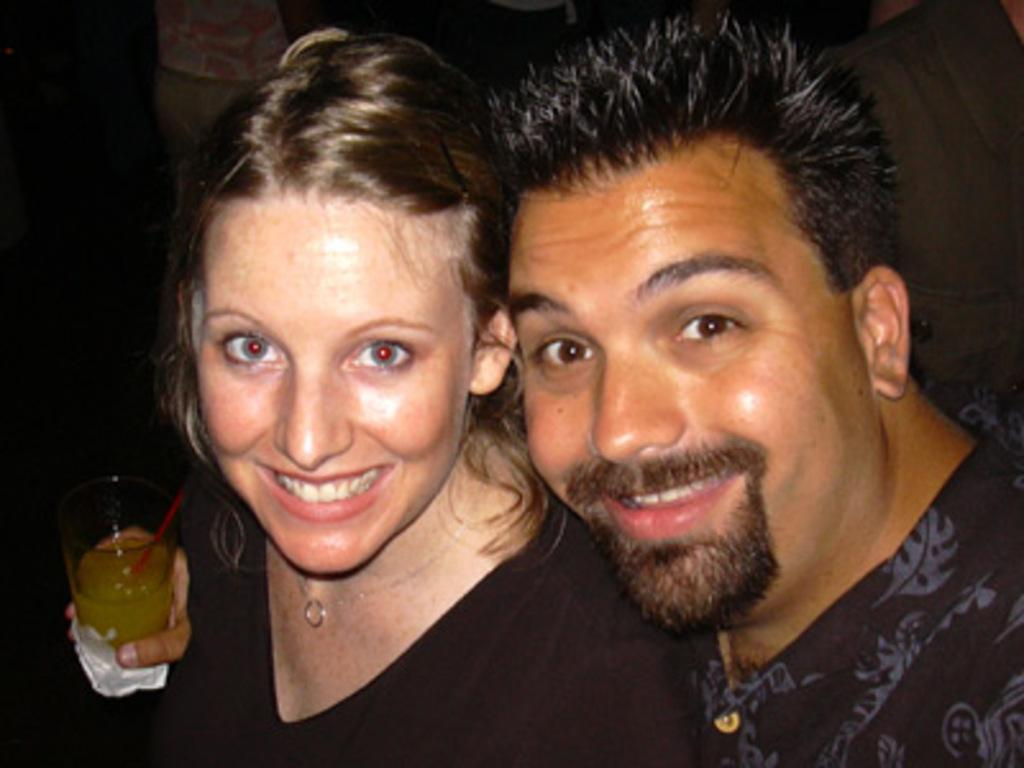What is the gender of the person in the image? There is a man in the image. What is the facial expression of the man in the image? The man is smiling. Are there any other people in the image? Yes, there is a woman in the image. What is the facial expression of the woman in the image? The woman is smiling. What object can be seen in the image? There is a glass in the image. Can you see any fairies flying around the man and woman in the image? There are no fairies present in the image. What type of pain is the man experiencing in the image? There is no indication of pain in the image; both the man and the woman are smiling. 